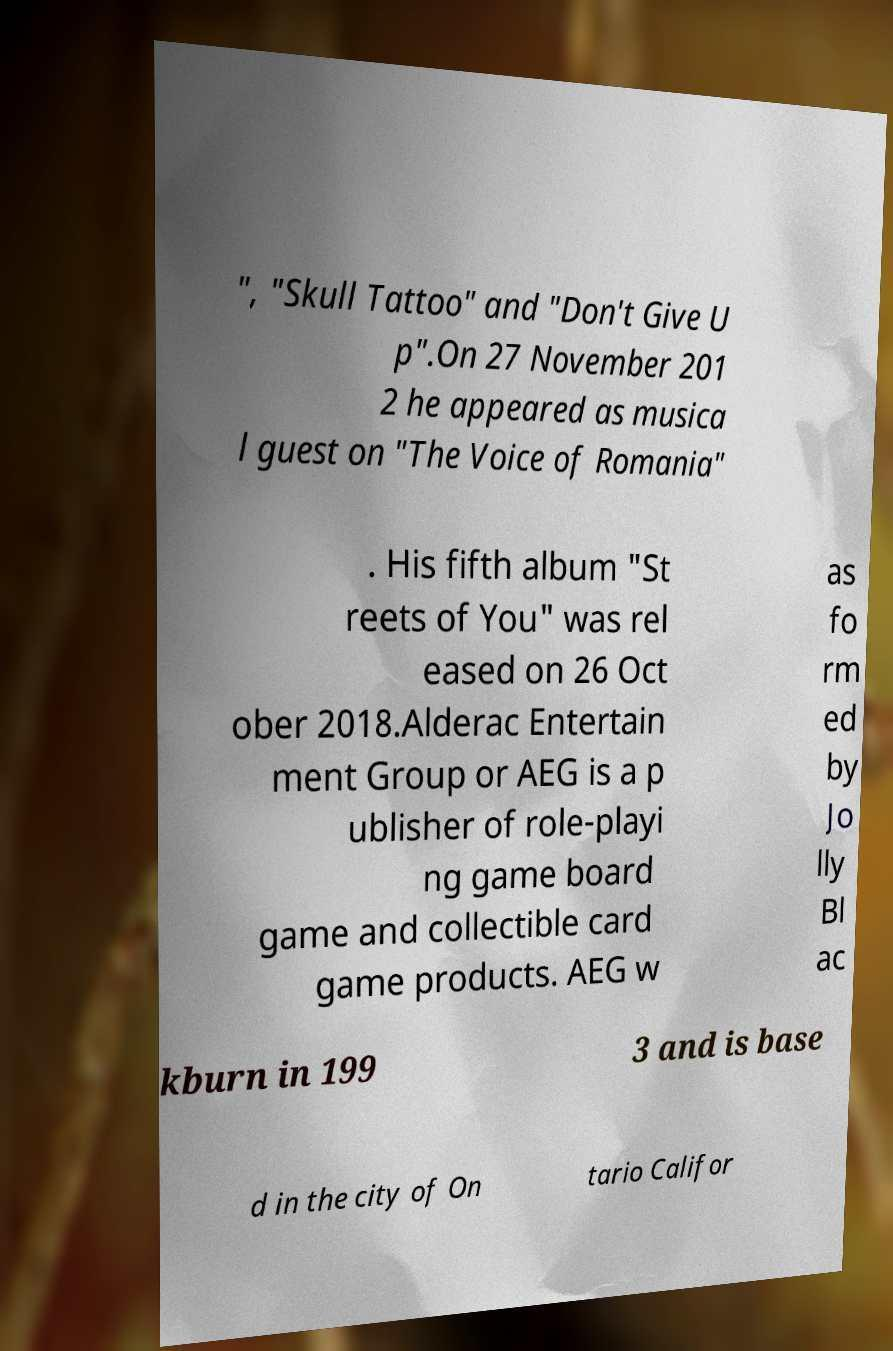I need the written content from this picture converted into text. Can you do that? ", "Skull Tattoo" and "Don't Give U p".On 27 November 201 2 he appeared as musica l guest on "The Voice of Romania" . His fifth album "St reets of You" was rel eased on 26 Oct ober 2018.Alderac Entertain ment Group or AEG is a p ublisher of role-playi ng game board game and collectible card game products. AEG w as fo rm ed by Jo lly Bl ac kburn in 199 3 and is base d in the city of On tario Califor 